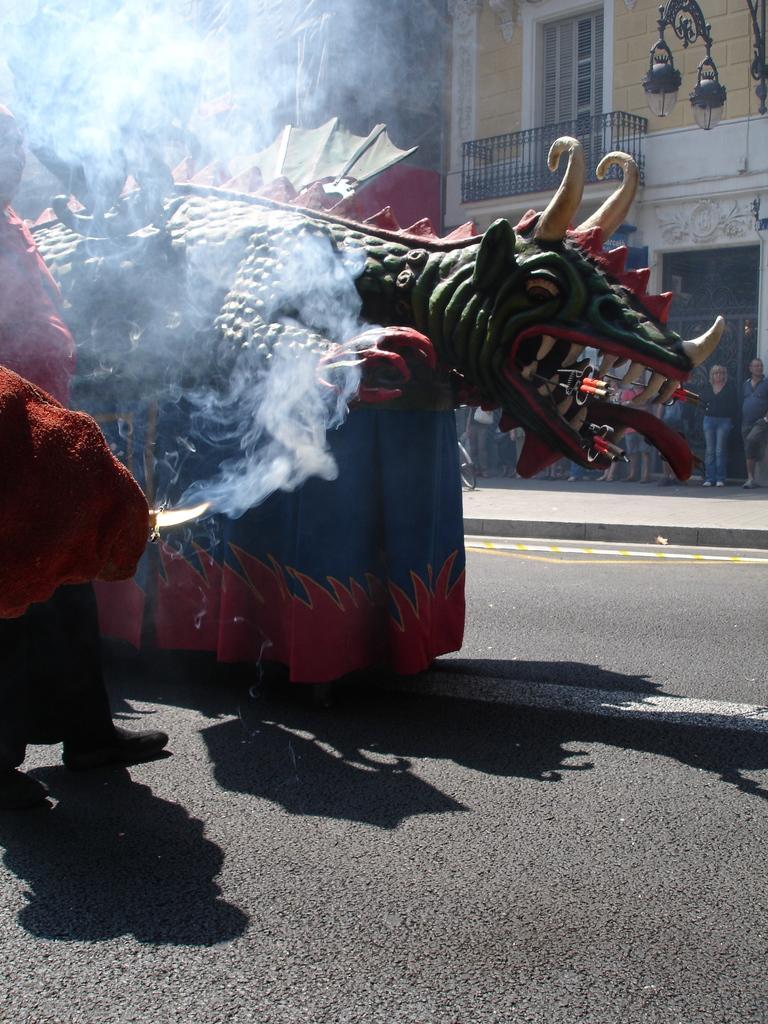Can you describe this image briefly? In this image we can see the depiction of the dinosaur. We can also see a man holding the small sword and standing on the road. In the background we can see the buildings, hanging light lamps and also a few people standing on the path. We can also see the smoke. 